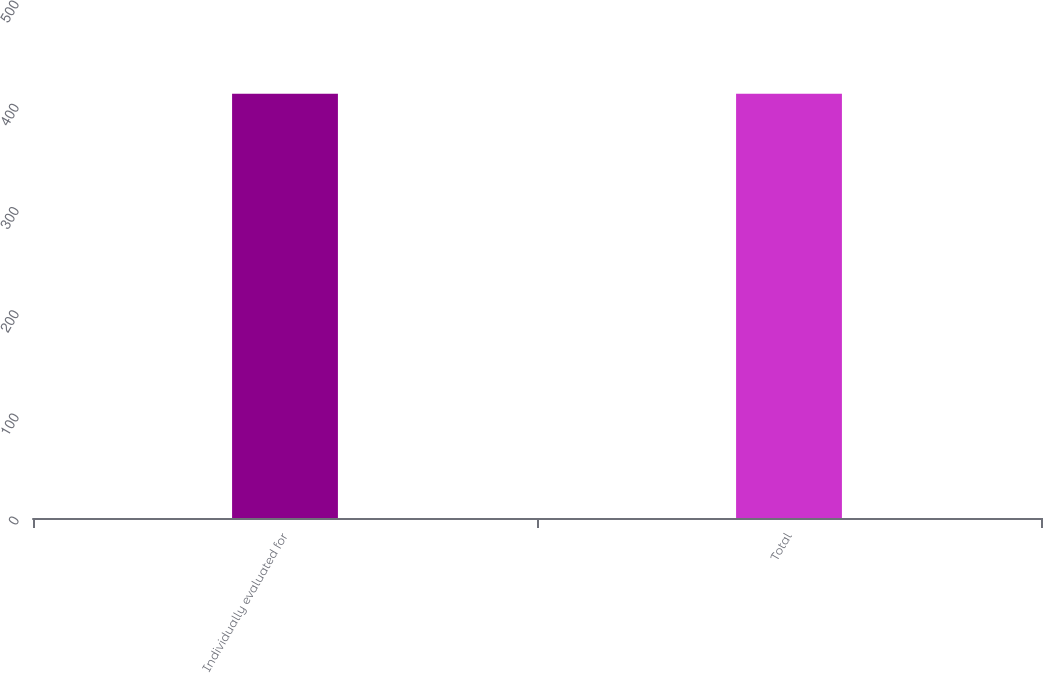Convert chart. <chart><loc_0><loc_0><loc_500><loc_500><bar_chart><fcel>Individually evaluated for<fcel>Total<nl><fcel>411<fcel>411.1<nl></chart> 